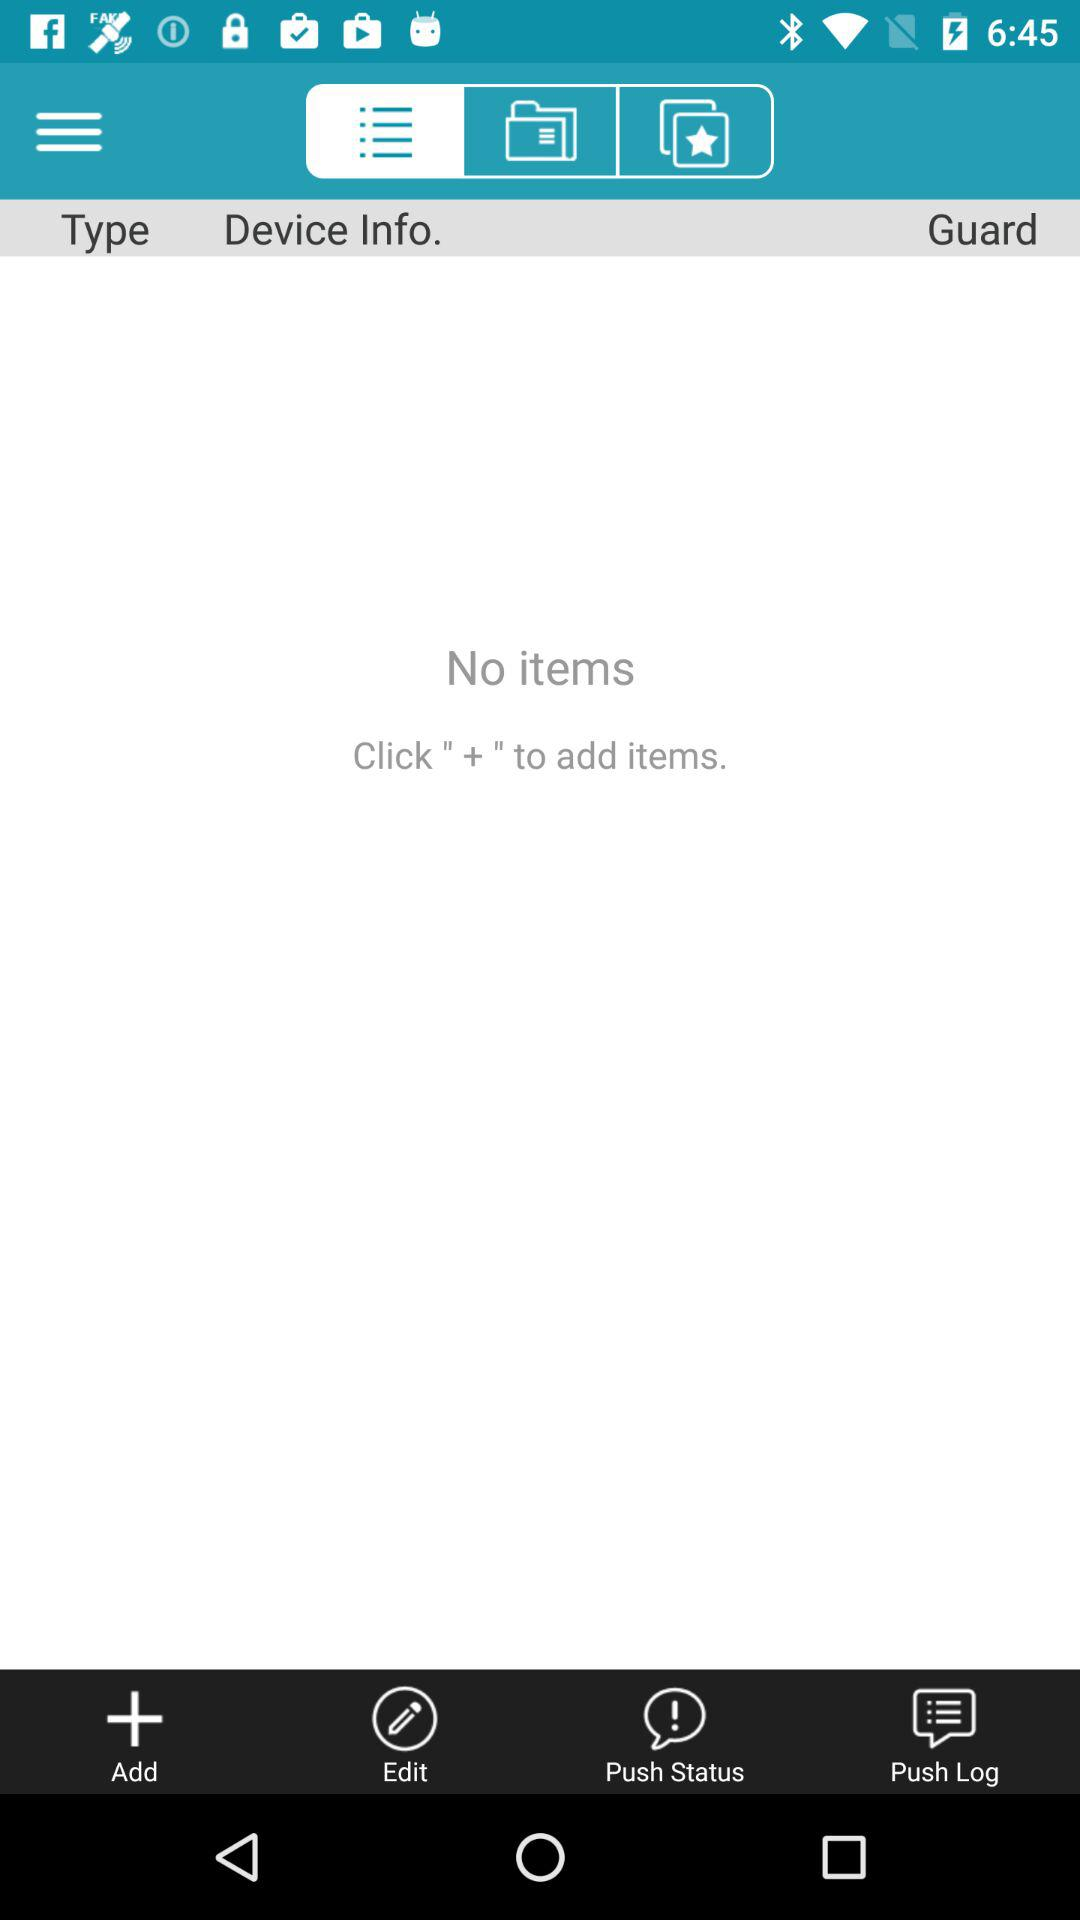Are there any items? There are no items. 